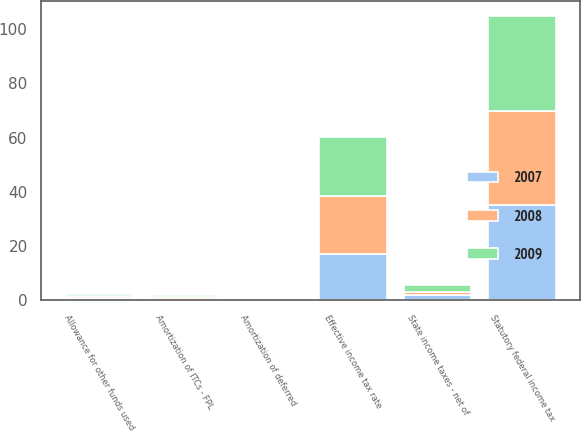Convert chart. <chart><loc_0><loc_0><loc_500><loc_500><stacked_bar_chart><ecel><fcel>Statutory federal income tax<fcel>State income taxes - net of<fcel>Allowance for other funds used<fcel>Amortization of ITCs - FPL<fcel>Amortization of deferred<fcel>Effective income tax rate<nl><fcel>2007<fcel>35<fcel>1.9<fcel>1<fcel>0.4<fcel>0.3<fcel>16.9<nl><fcel>2008<fcel>35<fcel>1.3<fcel>0.6<fcel>0.7<fcel>0.2<fcel>21.6<nl><fcel>2009<fcel>35<fcel>2.4<fcel>0.6<fcel>0.9<fcel>0.2<fcel>21.9<nl></chart> 